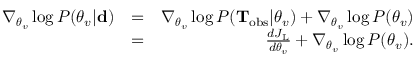Convert formula to latex. <formula><loc_0><loc_0><loc_500><loc_500>\begin{array} { r l r } { \nabla _ { \theta _ { v } } \log P ( \theta _ { v } | { d } ) } & { = } & { \nabla _ { \theta _ { v } } \log P ( T _ { o b s } | \theta _ { v } ) + \nabla _ { \theta _ { v } } \log P ( \theta _ { v } ) } \\ & { = } & { \frac { d J _ { L } } { d \theta _ { v } } + \nabla _ { \theta _ { v } } \log P ( \theta _ { v } ) . } \end{array}</formula> 